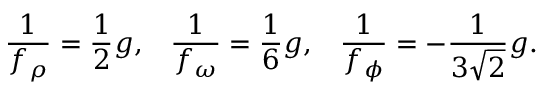<formula> <loc_0><loc_0><loc_500><loc_500>{ \frac { 1 } { f _ { \rho } } } = { \frac { 1 } { 2 } } g , \, { \frac { 1 } { f _ { \omega } } } = { \frac { 1 } { 6 } } g , \, { \frac { 1 } { f _ { \phi } } } = - { \frac { 1 } { 3 \sqrt { 2 } } } g .</formula> 